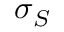Convert formula to latex. <formula><loc_0><loc_0><loc_500><loc_500>\sigma _ { S }</formula> 